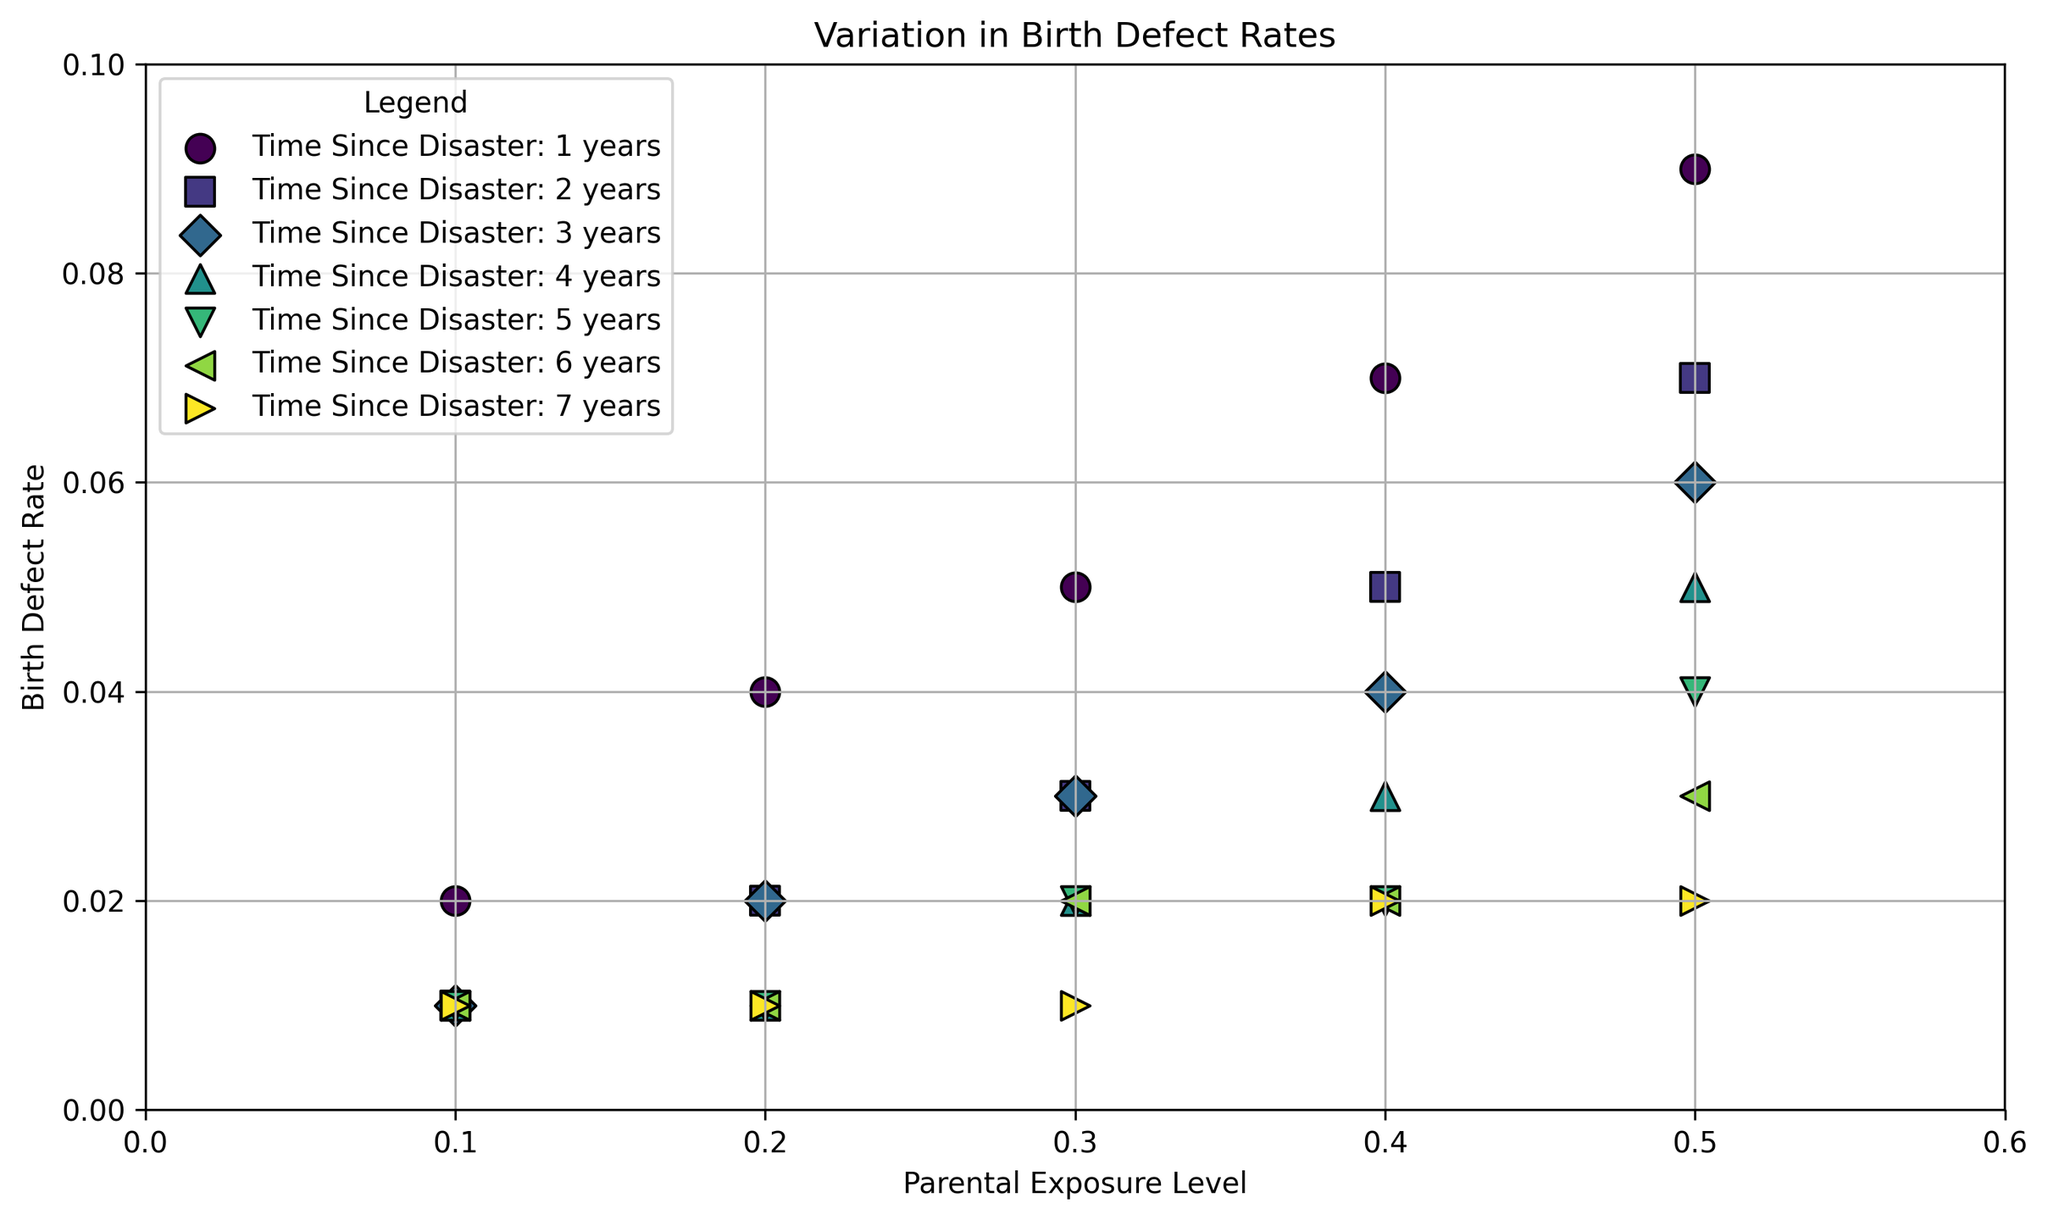What is the birth defect rate for a parental exposure level of 0.3 at 2 years since the disaster? To find this, locate the marker for Time Since Disaster: 2 years (with its unique color/marker) that aligns with the parental exposure level of 0.3. The plot shows this value as 0.03.
Answer: 0.03 How does the birth defect rate change over time for a parental exposure level of 0.5? Track the point corresponding to parental exposure level 0.5 for each time since the disaster (1-7 years). The rates are 0.09, 0.07, 0.06, 0.05, 0.04, 0.03, and 0.02, respectively, indicating a decreasing trend over time.
Answer: Decreases What is the highest birth defect rate at 1 year since the disaster and for which exposure level? Look for the highest point in the subset of data labeled "Time Since Disaster: 1 year" (specific color/marker). It is 0.09, at a parental exposure level of 0.5.
Answer: 0.09 at 0.5 exposure Compare the birth defect rates for exposure levels of 0.2 and 0.4 at 5 years since the disaster. Which is higher? Locate the markers for Time Since Disaster: 5 years, at exposure levels 0.2 and 0.4. The birth defect rates are 0.01 and 0.02 respectively, so 0.4 exposure is higher.
Answer: 0.4 exposure For a parental exposure level of 0.3, what is the difference in birth defect rate between 1 year and 7 years since the disaster? Find the markers for 0.3 exposure at 1 year and 7 years since the disaster (different colors/markers). The rates are 0.05 and 0.01 respectively. The difference is 0.05 - 0.01 = 0.04.
Answer: 0.04 What is the average birth defect rate for parental exposure levels of 0.4 and 0.5 at 4 years since the disaster? Locate the birth defect rates for 0.4 and 0.5 exposure at 4 years since the disaster (different markers/colors). The rates are 0.03 and 0.05 respectively. The average is (0.03 + 0.05) / 2 = 0.04.
Answer: 0.04 What trend do you observe in birth defect rates over time for parental exposure level 0.1? Track the point for 0.1 exposure over each year since the disaster. The rates are constant at 0.01, showing no change over time.
Answer: No change Among all time points, which parental exposure level shows the least increase in birth defect rates? Compare the increase in birth defect rates from 1 to 7 years for all exposure levels. Notice that the 0.1 exposure level remains constant at 0.01, hence it shows the least increase.
Answer: 0.1 exposure Do the birth defect rates for the highest parental exposure level show a consistent trend over time? Track the highest exposure level (0.5) across all years. The rates decrease from 0.09 to 0.02, showing a consistent downward trend.
Answer: Yes, decreasing Calculate the total cumulative birth defect rate for a parental exposure level of 0.4 over all the recorded years. Sum the rates for 0.4 exposure over all years: 0.07 (year 1), 0.05 (year 2), 0.04 (year 3), 0.03 (year 4), 0.02 (year 5), 0.02 (year 6), 0.02 (year 7). The total is 0.07 + 0.05 + 0.04 + 0.03 + 0.02 + 0.02 + 0.02 = 0.25.
Answer: 0.25 